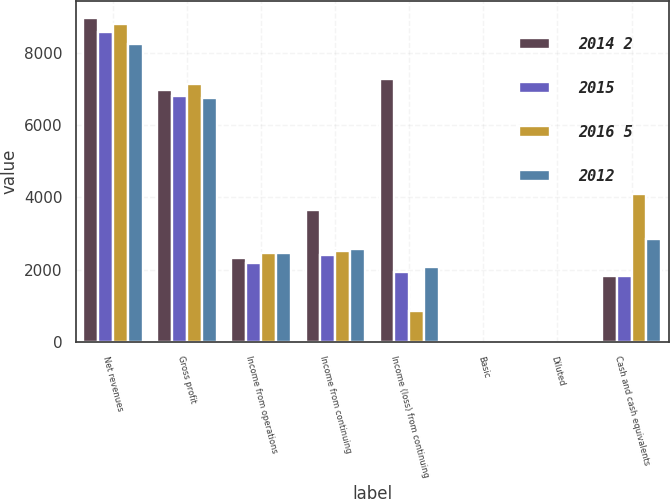<chart> <loc_0><loc_0><loc_500><loc_500><stacked_bar_chart><ecel><fcel>Net revenues<fcel>Gross profit<fcel>Income from operations<fcel>Income from continuing<fcel>Income (loss) from continuing<fcel>Basic<fcel>Diluted<fcel>Cash and cash equivalents<nl><fcel>2014 2<fcel>8979<fcel>6972<fcel>2325<fcel>3651<fcel>7285<fcel>6.43<fcel>6.37<fcel>1816<nl><fcel>2015<fcel>8592<fcel>6821<fcel>2197<fcel>2406<fcel>1947<fcel>1.61<fcel>1.6<fcel>1832<nl><fcel>2016 5<fcel>8790<fcel>7127<fcel>2476<fcel>2515<fcel>865<fcel>0.69<fcel>0.69<fcel>4105<nl><fcel>2012<fcel>8257<fcel>6765<fcel>2454<fcel>2571<fcel>2067<fcel>1.6<fcel>1.57<fcel>2848<nl></chart> 